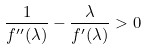<formula> <loc_0><loc_0><loc_500><loc_500>\frac { 1 } { f ^ { \prime \prime } ( \lambda ) } - \frac { \lambda } { f ^ { \prime } ( \lambda ) } > 0</formula> 